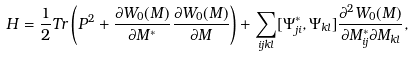<formula> <loc_0><loc_0><loc_500><loc_500>H = \frac { 1 } { 2 } T r \left ( P ^ { 2 } + \frac { \partial W _ { 0 } ( M ) } { \partial M ^ { * } } \frac { \partial W _ { 0 } ( M ) } { \partial M } \right ) + \sum _ { i j k l } [ \Psi _ { j i } ^ { * } , \Psi _ { k l } ] \frac { \partial ^ { 2 } W _ { 0 } ( M ) } { \partial M ^ { * } _ { i j } \partial M _ { k l } } ,</formula> 